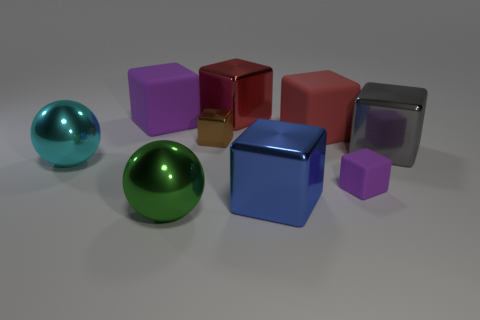Add 1 blue objects. How many objects exist? 10 Subtract all cubes. How many objects are left? 2 Subtract all cyan balls. How many balls are left? 1 Subtract all big shiny cubes. How many cubes are left? 4 Subtract all red cubes. How many purple balls are left? 0 Subtract all tiny brown shiny objects. Subtract all purple blocks. How many objects are left? 6 Add 1 green balls. How many green balls are left? 2 Add 5 tiny green metallic cylinders. How many tiny green metallic cylinders exist? 5 Subtract 0 cyan blocks. How many objects are left? 9 Subtract 1 balls. How many balls are left? 1 